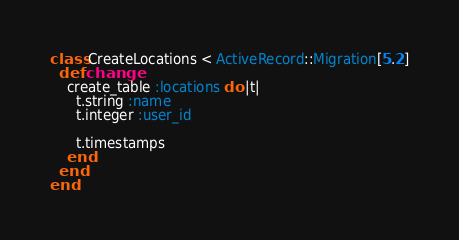<code> <loc_0><loc_0><loc_500><loc_500><_Ruby_>class CreateLocations < ActiveRecord::Migration[5.2]
  def change
    create_table :locations do |t|
      t.string :name
      t.integer :user_id

      t.timestamps
    end
  end
end
</code> 